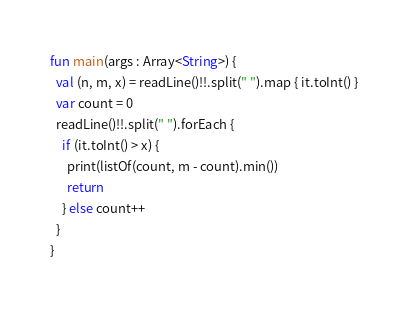Convert code to text. <code><loc_0><loc_0><loc_500><loc_500><_Kotlin_>fun main(args : Array<String>) {
  val (n, m, x) = readLine()!!.split(" ").map { it.toInt() }
  var count = 0
  readLine()!!.split(" ").forEach {
    if (it.toInt() > x) {
      print(listOf(count, m - count).min())
      return
    } else count++
  }
}</code> 